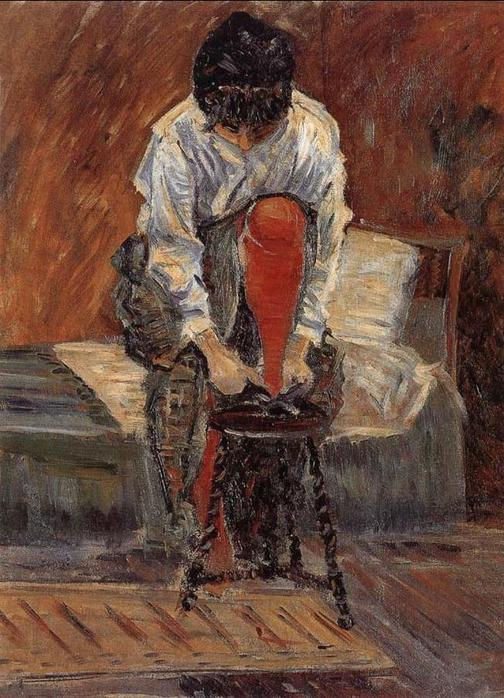Describe the following image. This image portrays an Impressionist painting featuring a woman dressed in a loose white blouse and vibrant red skirt, deep in concentration while sitting on a wooden chair. The setting is intimate, marked by a warm palette of browns and reds that create a comforting yet introspective atmosphere. She appears absorbed in a thoughtful activity, perhaps reading or writing, suggested by her downward gaze and the positioning of her hands. The rustic, wooden textures and the simplicity of the room with its bare white wall emphasize a moment of everyday life, captured with a focus on personal experience and emotional depth typical of Impressionist art. The painting not only depicts a scene but also evokes a mood of solitude and silent reflection. 